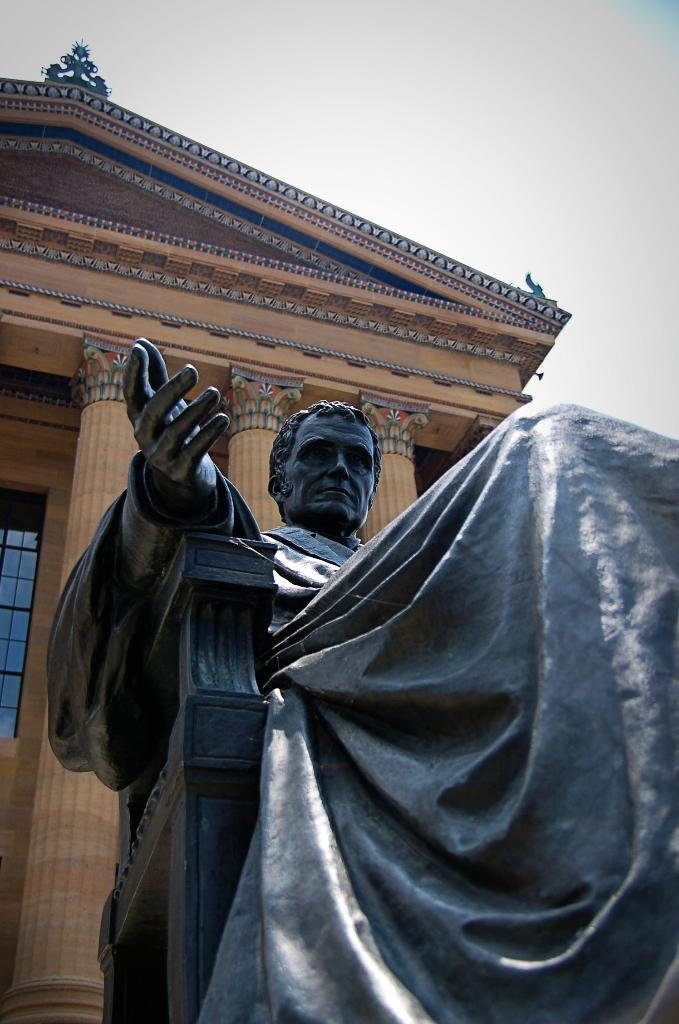What is the main subject in the foreground of the image? There is a statue of a man in the foreground of the image. What can be seen in the background of the image? There is a building in the background of the image. How would you describe the sky in the image? The sky is clear in the image. What is the name of the veil worn by the man in the image? There is no veil present in the image, as the main subject is a statue of a man. 